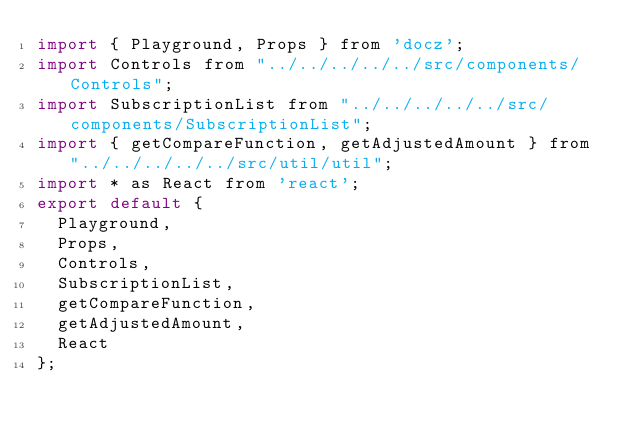<code> <loc_0><loc_0><loc_500><loc_500><_JavaScript_>import { Playground, Props } from 'docz';
import Controls from "../../../../../src/components/Controls";
import SubscriptionList from "../../../../../src/components/SubscriptionList";
import { getCompareFunction, getAdjustedAmount } from "../../../../../src/util/util";
import * as React from 'react';
export default {
  Playground,
  Props,
  Controls,
  SubscriptionList,
  getCompareFunction,
  getAdjustedAmount,
  React
};</code> 